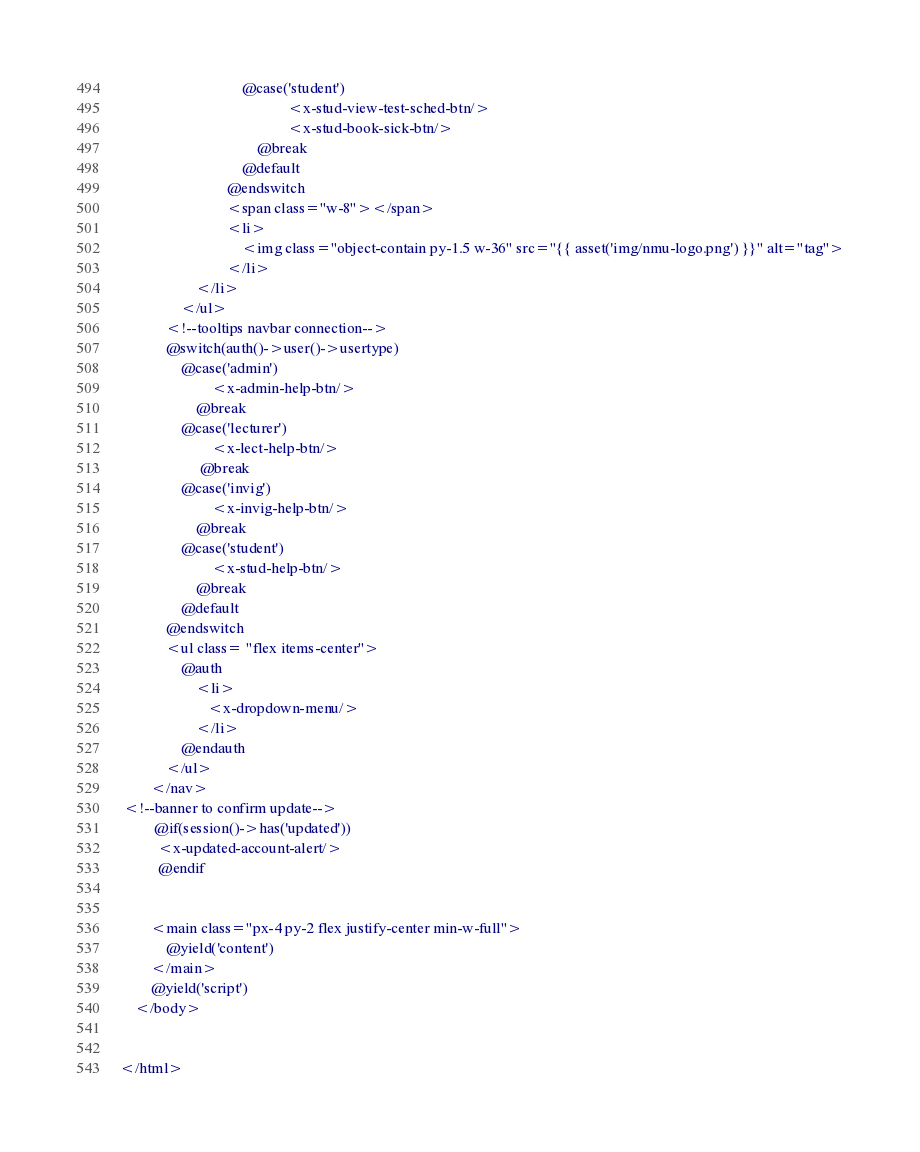Convert code to text. <code><loc_0><loc_0><loc_500><loc_500><_PHP_>                                @case('student')
                                            <x-stud-view-test-sched-btn/>
                                            <x-stud-book-sick-btn/>
                                    @break
                                @default
                            @endswitch
                            <span class="w-8"></span>
                            <li>
                                <img class="object-contain py-1.5 w-36" src="{{ asset('img/nmu-logo.png') }}" alt="tag">
                            </li>
                    </li>
                </ul>
            <!--tooltips navbar connection-->
            @switch(auth()->user()->usertype)
                @case('admin')
                        <x-admin-help-btn/>
                    @break
                @case('lecturer')
                        <x-lect-help-btn/>
                     @break
                @case('invig')
                        <x-invig-help-btn/>
                    @break
                @case('student')
                        <x-stud-help-btn/>
                    @break
                @default
            @endswitch
            <ul class= "flex items-center">
                @auth
                    <li>
                       <x-dropdown-menu/>
                    </li>
                @endauth
            </ul>
        </nav>
 <!--banner to confirm update-->
         @if(session()->has('updated'))
          <x-updated-account-alert/>
          @endif


        <main class="px-4 py-2 flex justify-center min-w-full">
            @yield('content')
        </main>
        @yield('script')
    </body>


</html>
</code> 